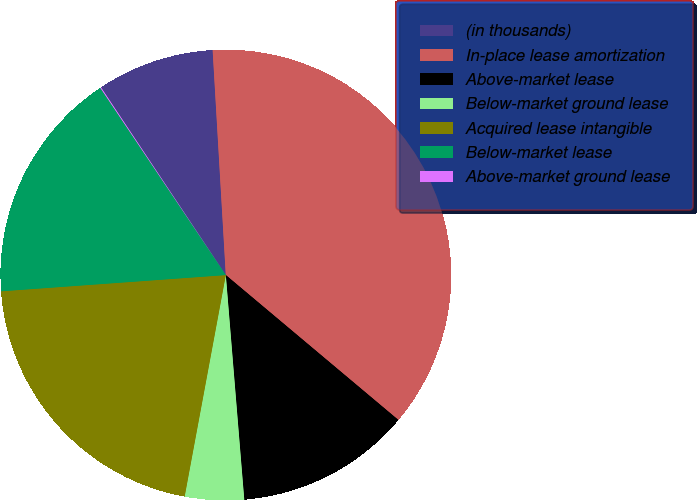Convert chart. <chart><loc_0><loc_0><loc_500><loc_500><pie_chart><fcel>(in thousands)<fcel>In-place lease amortization<fcel>Above-market lease<fcel>Below-market ground lease<fcel>Acquired lease intangible<fcel>Below-market lease<fcel>Above-market ground lease<nl><fcel>8.41%<fcel>37.05%<fcel>12.58%<fcel>4.23%<fcel>20.93%<fcel>16.75%<fcel>0.06%<nl></chart> 